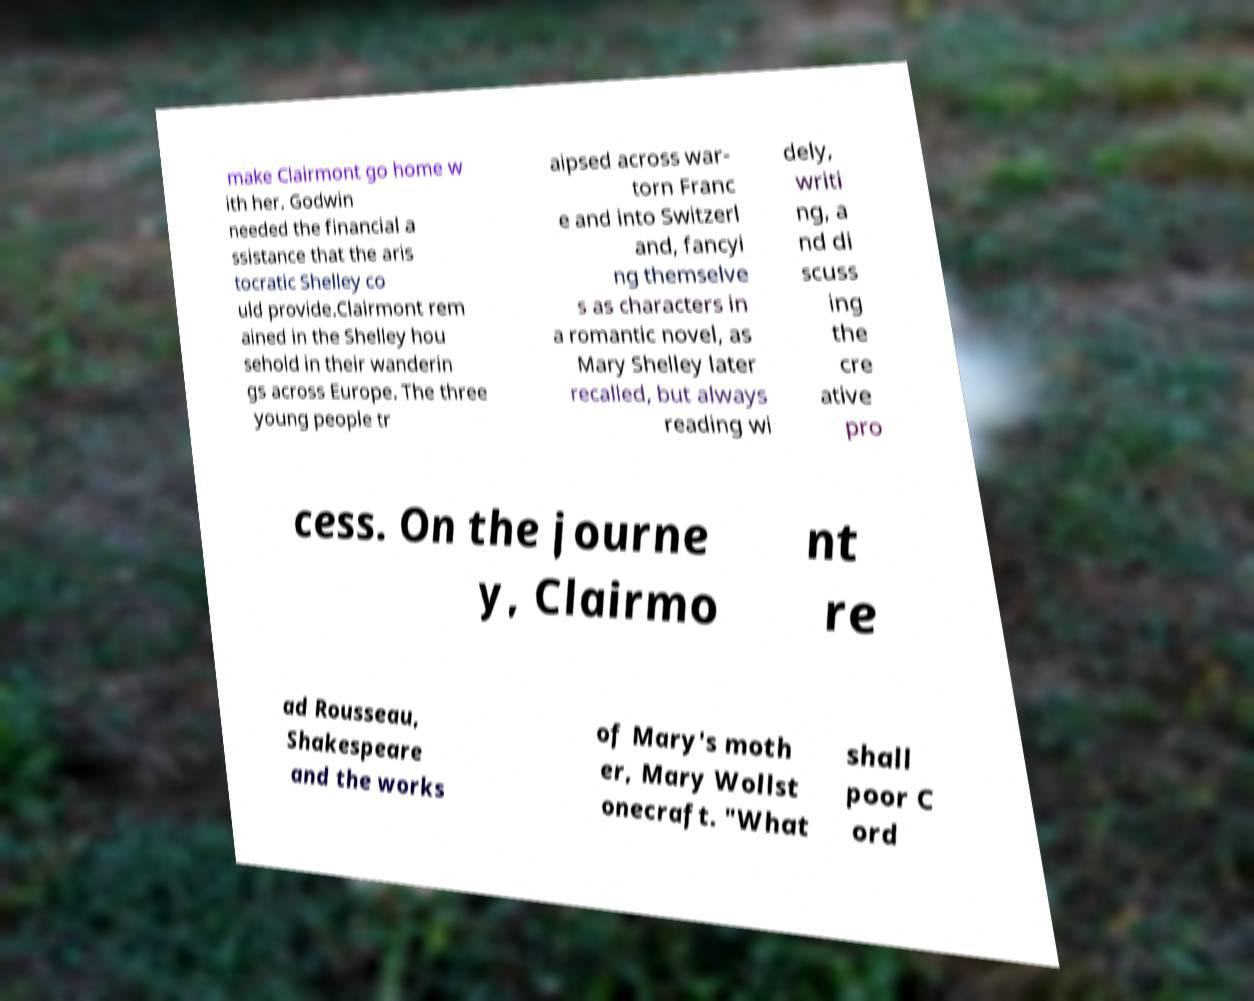What messages or text are displayed in this image? I need them in a readable, typed format. make Clairmont go home w ith her. Godwin needed the financial a ssistance that the aris tocratic Shelley co uld provide.Clairmont rem ained in the Shelley hou sehold in their wanderin gs across Europe. The three young people tr aipsed across war- torn Franc e and into Switzerl and, fancyi ng themselve s as characters in a romantic novel, as Mary Shelley later recalled, but always reading wi dely, writi ng, a nd di scuss ing the cre ative pro cess. On the journe y, Clairmo nt re ad Rousseau, Shakespeare and the works of Mary's moth er, Mary Wollst onecraft. "What shall poor C ord 